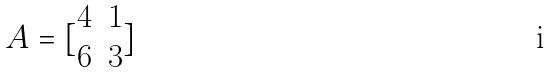<formula> <loc_0><loc_0><loc_500><loc_500>A = [ \begin{matrix} 4 & 1 \\ 6 & 3 \end{matrix} ]</formula> 